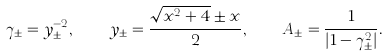Convert formula to latex. <formula><loc_0><loc_0><loc_500><loc_500>\gamma _ { \pm } = y _ { \pm } ^ { - 2 } , \quad y _ { \pm } = \frac { \sqrt { x ^ { 2 } + 4 } \pm x } { 2 } , \quad A _ { \pm } = \frac { 1 } { | 1 - \gamma _ { \pm } ^ { 2 } | } .</formula> 